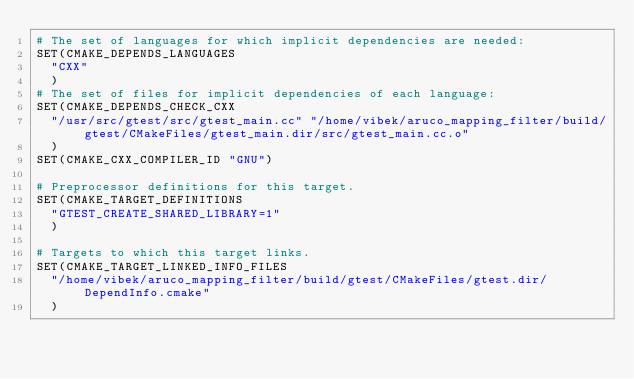Convert code to text. <code><loc_0><loc_0><loc_500><loc_500><_CMake_># The set of languages for which implicit dependencies are needed:
SET(CMAKE_DEPENDS_LANGUAGES
  "CXX"
  )
# The set of files for implicit dependencies of each language:
SET(CMAKE_DEPENDS_CHECK_CXX
  "/usr/src/gtest/src/gtest_main.cc" "/home/vibek/aruco_mapping_filter/build/gtest/CMakeFiles/gtest_main.dir/src/gtest_main.cc.o"
  )
SET(CMAKE_CXX_COMPILER_ID "GNU")

# Preprocessor definitions for this target.
SET(CMAKE_TARGET_DEFINITIONS
  "GTEST_CREATE_SHARED_LIBRARY=1"
  )

# Targets to which this target links.
SET(CMAKE_TARGET_LINKED_INFO_FILES
  "/home/vibek/aruco_mapping_filter/build/gtest/CMakeFiles/gtest.dir/DependInfo.cmake"
  )
</code> 